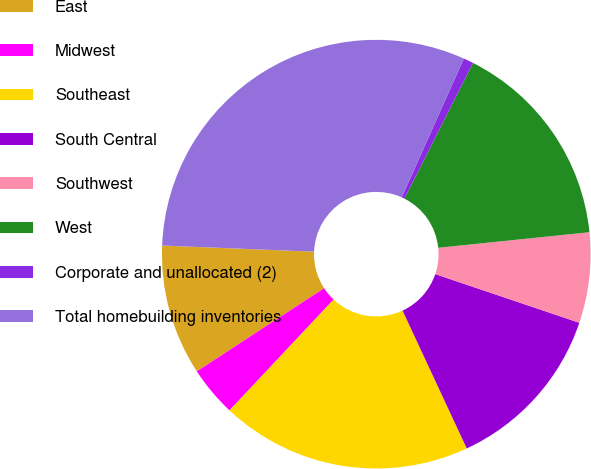Convert chart to OTSL. <chart><loc_0><loc_0><loc_500><loc_500><pie_chart><fcel>East<fcel>Midwest<fcel>Southeast<fcel>South Central<fcel>Southwest<fcel>West<fcel>Corporate and unallocated (2)<fcel>Total homebuilding inventories<nl><fcel>9.85%<fcel>3.79%<fcel>18.94%<fcel>12.88%<fcel>6.82%<fcel>15.91%<fcel>0.76%<fcel>31.06%<nl></chart> 